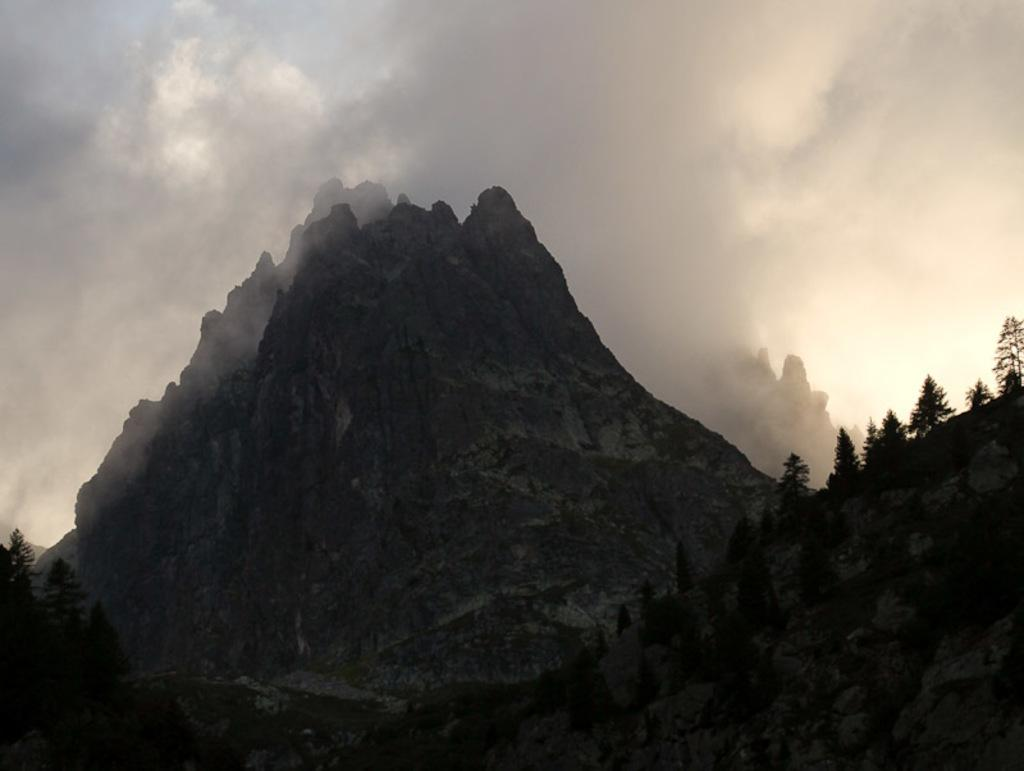What type of natural landform can be seen in the image? There are hills in the image. What type of vegetation is present in the image? There are trees in the image. What can be seen coming from the hills in the image? There is smoke visible in the image. What is visible in the background of the image? The sky is visible in the background of the image. What type of beef is being cooked in the image? There is no beef present in the image; it features hills, trees, smoke, and the sky. Can you see a robin perched on any of the trees in the image? There is no robin present in the image; it only features hills, trees, smoke, and the sky. 